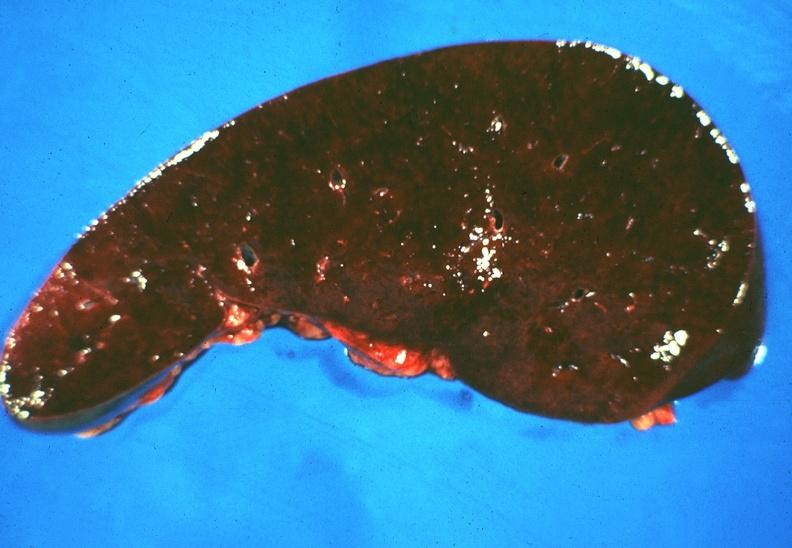does this image show spleen, hemochromatosis?
Answer the question using a single word or phrase. Yes 